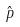Convert formula to latex. <formula><loc_0><loc_0><loc_500><loc_500>\hat { p }</formula> 